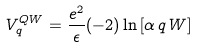Convert formula to latex. <formula><loc_0><loc_0><loc_500><loc_500>V ^ { Q W } _ { q } = \frac { e ^ { 2 } } { \epsilon } ( - 2 ) \ln { \left [ \alpha \, q \, W \right ] }</formula> 